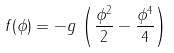Convert formula to latex. <formula><loc_0><loc_0><loc_500><loc_500>f ( \phi ) = - g \, \left ( \frac { \phi ^ { 2 } } { 2 } - \frac { \phi ^ { 4 } } { 4 } \right )</formula> 